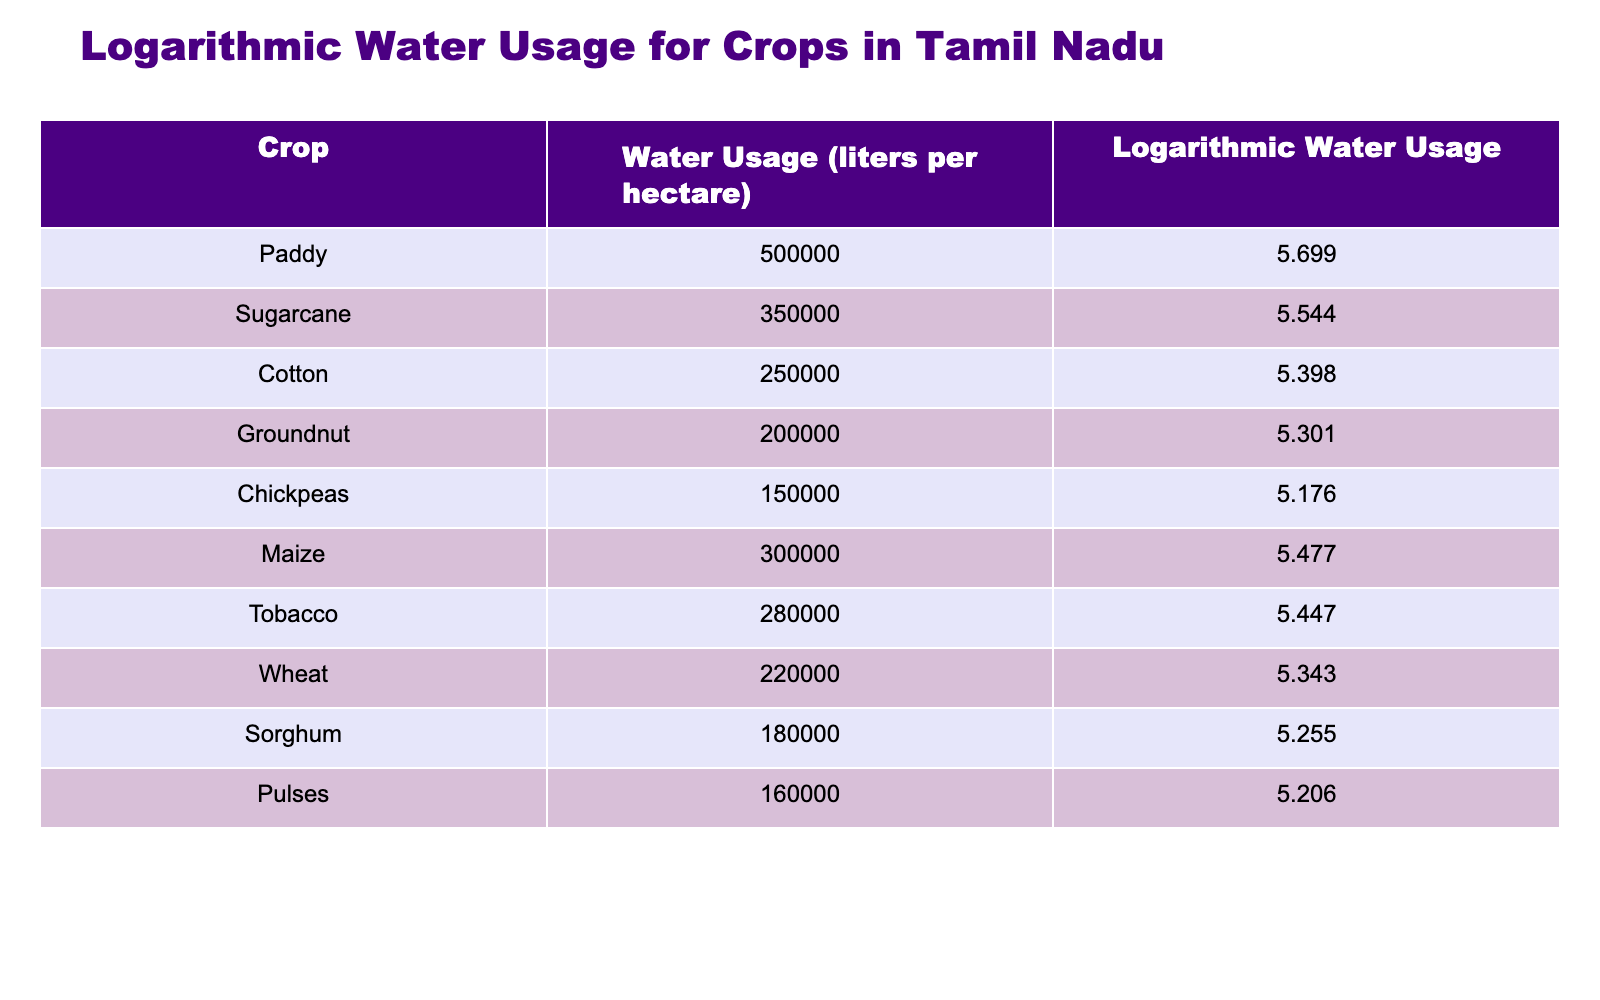What is the water usage for Paddy in liters per hectare? The table directly lists the water usage for each crop, and for Paddy, the specific value is provided in the "Water Usage (liters per hectare)" column. The value for Paddy is 500,000 liters.
Answer: 500000 Which crop has the highest water usage? By examining the "Water Usage (liters per hectare)" column, we can compare the values of all listed crops. Paddy has the highest value at 500,000 liters compared to the others.
Answer: Paddy Calculate the average water usage for Cotton, Groundnut, and Chickpeas. The water usages for these crops are Cotton: 250,000 liters, Groundnut: 200,000 liters, and Chickpeas: 150,000 liters. First, we sum them: 250,000 + 200,000 + 150,000 = 600,000 liters. Then, we divide by the number of crops, which is 3: 600,000 / 3 = 200,000 liters.
Answer: 200000 Is the water usage for Wheat greater than that of Maize? We compare the water usage values for Wheat (220,000 liters) and Maize (300,000 liters) by checking the corresponding rows in the table. Since 220,000 is less than 300,000, the statement is false.
Answer: No If you sum the water usage for Sorghum and Pulses, what is the total? The water usage for Sorghum is 180,000 liters and for Pulses is 160,000 liters. Summing these gives us 180,000 + 160,000 = 340,000 liters.
Answer: 340000 Which crop uses less water, Tobacco or Maize? The table shows that Tobacco has a water usage of 280,000 liters and Maize has a water usage of 300,000 liters. Comparing these two values reveals that Tobacco uses less water than Maize.
Answer: Yes What is the logarithmic water usage for Groundnut? The table provides a specific logarithmic water usage value for each crop. For Groundnut, the value found in the "Logarithmic Water Usage" column is 5.301.
Answer: 5.301 Which two crops have water usage that is closest together? By reviewing the water usage values in the table, we compare the differences: Sugarcane (350,000) and Maize (300,000) have a difference of 50,000; Tobacco (280,000) and Cotton (250,000) have a difference of 30,000; the smallest difference is between Groundnut and Chickpeas, with values 200,000 and 150,000, respectively, giving a difference of 50,000. Thus, the closest are Cotton and Tobacco at 30,000 liters apart.
Answer: Tobacco and Cotton What is the difference in water usage between Chickpeas and Groundnut? From the table, Chickpeas has a water usage of 150,000 liters and Groundnut has 200,000 liters. To find the difference, we subtract the smaller value from the larger value: 200,000 - 150,000 = 50,000 liters.
Answer: 50000 